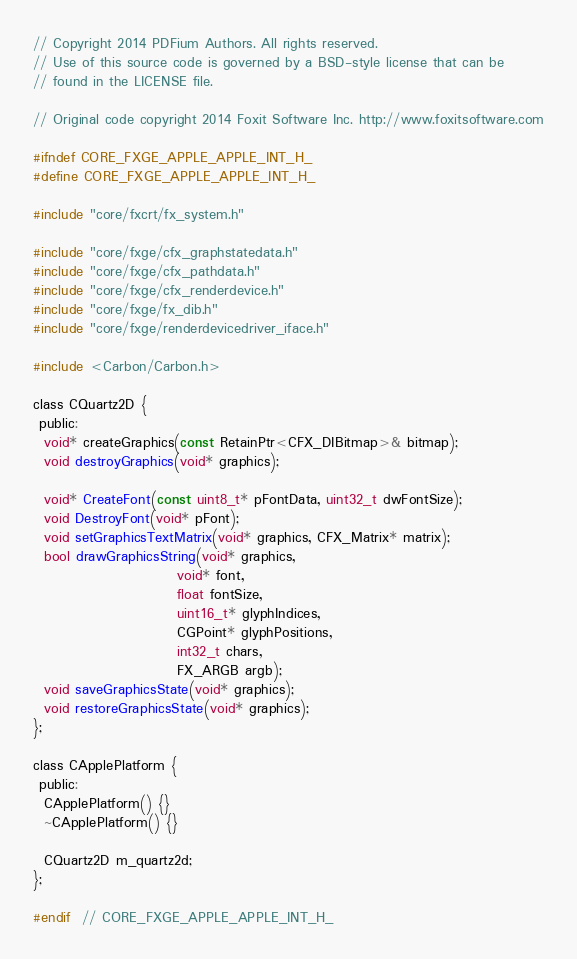<code> <loc_0><loc_0><loc_500><loc_500><_C_>// Copyright 2014 PDFium Authors. All rights reserved.
// Use of this source code is governed by a BSD-style license that can be
// found in the LICENSE file.

// Original code copyright 2014 Foxit Software Inc. http://www.foxitsoftware.com

#ifndef CORE_FXGE_APPLE_APPLE_INT_H_
#define CORE_FXGE_APPLE_APPLE_INT_H_

#include "core/fxcrt/fx_system.h"

#include "core/fxge/cfx_graphstatedata.h"
#include "core/fxge/cfx_pathdata.h"
#include "core/fxge/cfx_renderdevice.h"
#include "core/fxge/fx_dib.h"
#include "core/fxge/renderdevicedriver_iface.h"

#include <Carbon/Carbon.h>

class CQuartz2D {
 public:
  void* createGraphics(const RetainPtr<CFX_DIBitmap>& bitmap);
  void destroyGraphics(void* graphics);

  void* CreateFont(const uint8_t* pFontData, uint32_t dwFontSize);
  void DestroyFont(void* pFont);
  void setGraphicsTextMatrix(void* graphics, CFX_Matrix* matrix);
  bool drawGraphicsString(void* graphics,
                          void* font,
                          float fontSize,
                          uint16_t* glyphIndices,
                          CGPoint* glyphPositions,
                          int32_t chars,
                          FX_ARGB argb);
  void saveGraphicsState(void* graphics);
  void restoreGraphicsState(void* graphics);
};

class CApplePlatform {
 public:
  CApplePlatform() {}
  ~CApplePlatform() {}

  CQuartz2D m_quartz2d;
};

#endif  // CORE_FXGE_APPLE_APPLE_INT_H_
</code> 